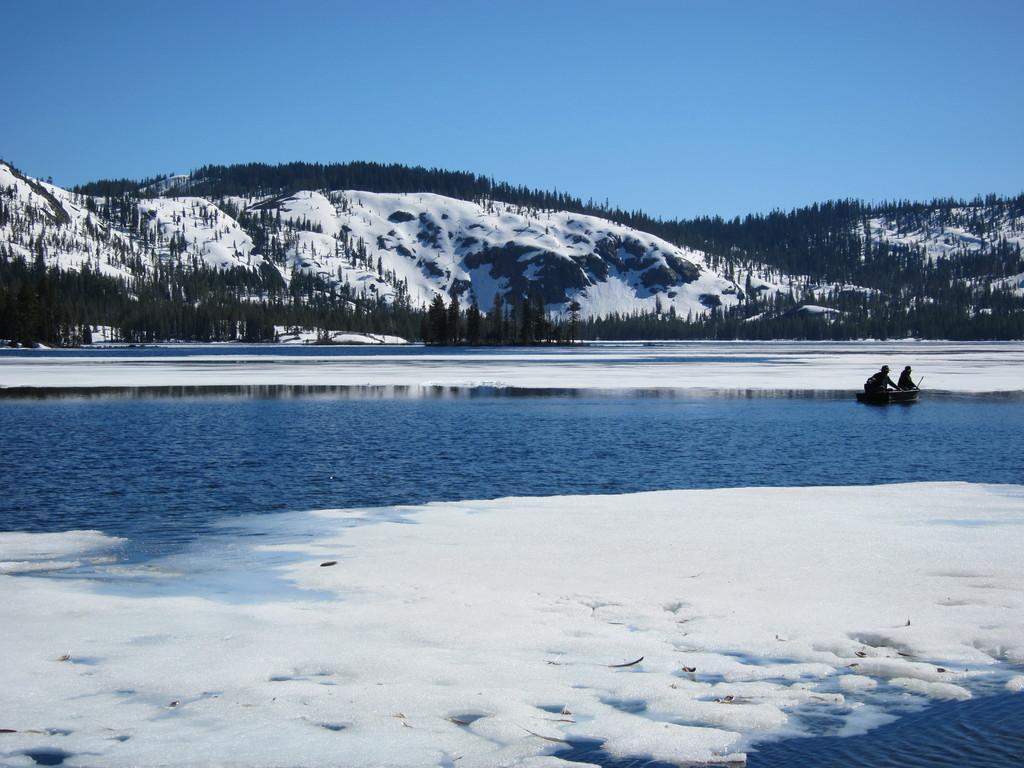Please provide a concise description of this image. In this image at the bottom there is a pond and snow, on the right side of the image there is one boat. In the boat there are two people sitting, and in the background there are mountains, trees and snow and at the top there is sky. 